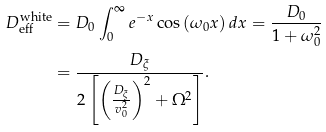Convert formula to latex. <formula><loc_0><loc_0><loc_500><loc_500>D _ { \text {eff} } ^ { \text {white} } & = D _ { 0 } \int _ { 0 } ^ { \infty } e ^ { - x } \cos \left ( \omega _ { 0 } x \right ) d x = \frac { D _ { 0 } } { 1 + \omega _ { 0 } ^ { 2 } } \\ & = \frac { D _ { \xi } } { 2 \left [ \left ( \frac { D _ { \xi } } { v _ { 0 } ^ { 2 } } \right ) ^ { 2 } + \Omega ^ { 2 } \right ] } .</formula> 